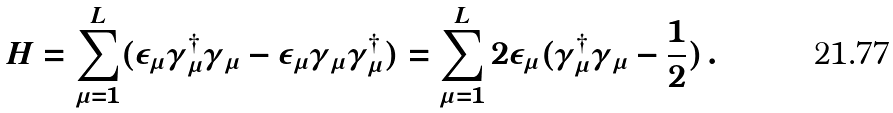Convert formula to latex. <formula><loc_0><loc_0><loc_500><loc_500>H = \sum _ { \mu = 1 } ^ { L } ( \epsilon _ { \mu } \gamma ^ { \dagger } _ { \mu } \gamma _ { \mu } - \epsilon _ { \mu } \gamma _ { \mu } \gamma ^ { \dagger } _ { \mu } ) = \sum _ { \mu = 1 } ^ { L } 2 \epsilon _ { \mu } ( \gamma _ { \mu } ^ { \dagger } \gamma _ { \mu } - \frac { 1 } { 2 } ) \, .</formula> 